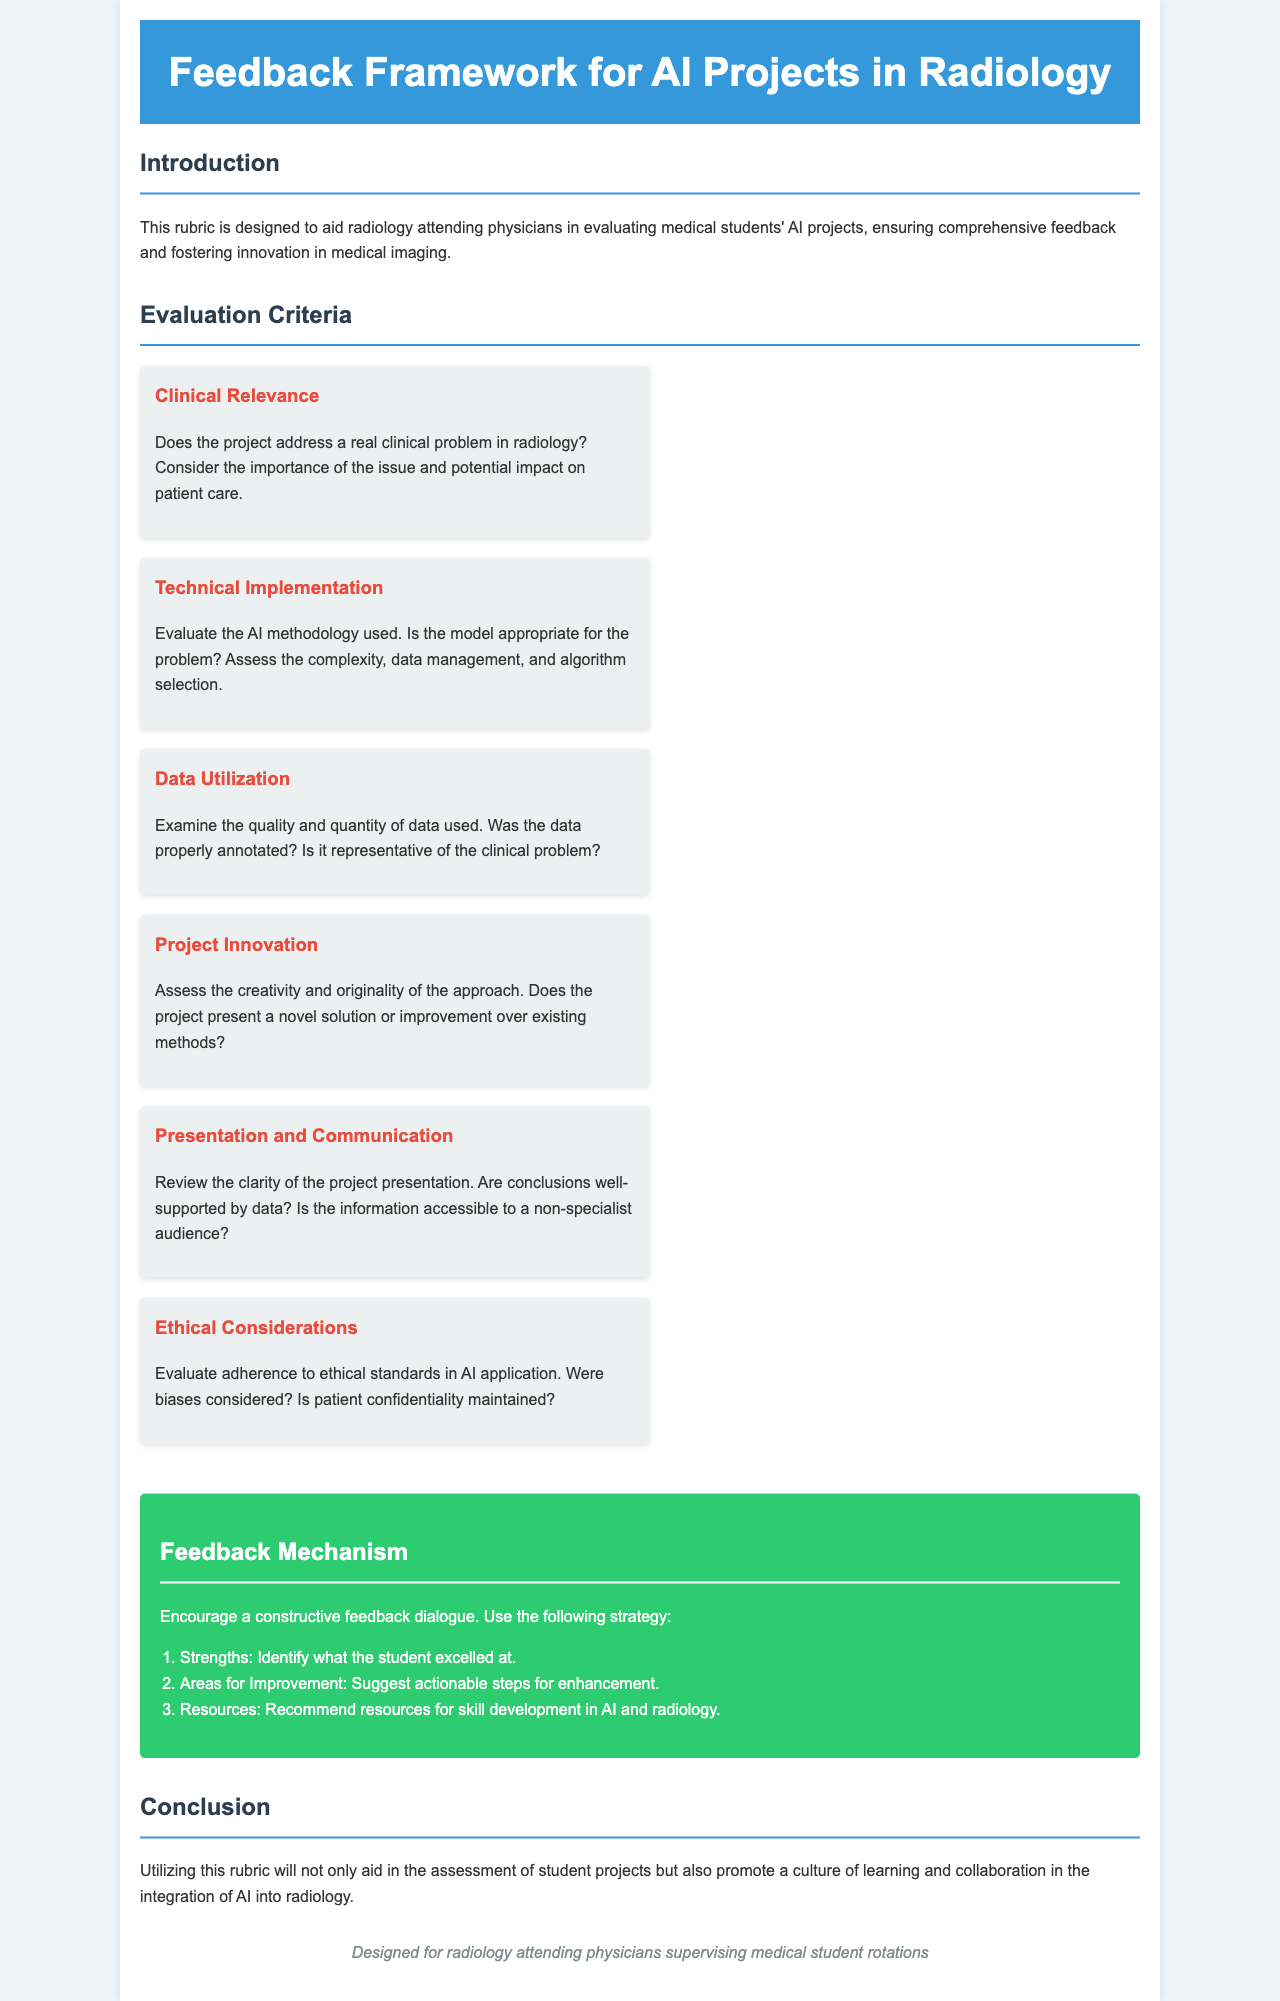What is the main purpose of the rubric? The rubric is designed to aid radiology attending physicians in evaluating medical students' AI projects, ensuring comprehensive feedback and fostering innovation in medical imaging.
Answer: Aid evaluation How many evaluation criteria are listed in the document? The document lists six evaluation criteria for assessing the projects.
Answer: Six What should be identified as a project strength? The document suggests identifying what the student excelled at when providing feedback.
Answer: Strengths Which criterion assesses patient confidentiality? The criterion that evaluates adherence to ethical standards in AI application includes patient confidentiality considerations.
Answer: Ethical Considerations What color is used for the feedback mechanism section? The feedback mechanism section is highlighted with a green background color.
Answer: Green What is the first step in the feedback mechanism? The first step is to identify what the student excelled at in their project.
Answer: Strengths 